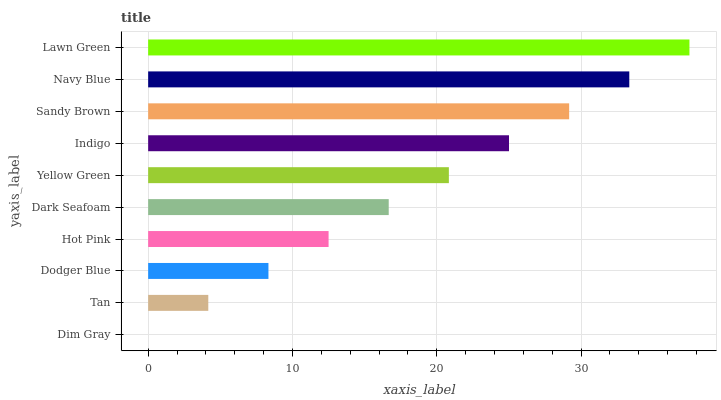Is Dim Gray the minimum?
Answer yes or no. Yes. Is Lawn Green the maximum?
Answer yes or no. Yes. Is Tan the minimum?
Answer yes or no. No. Is Tan the maximum?
Answer yes or no. No. Is Tan greater than Dim Gray?
Answer yes or no. Yes. Is Dim Gray less than Tan?
Answer yes or no. Yes. Is Dim Gray greater than Tan?
Answer yes or no. No. Is Tan less than Dim Gray?
Answer yes or no. No. Is Yellow Green the high median?
Answer yes or no. Yes. Is Dark Seafoam the low median?
Answer yes or no. Yes. Is Dim Gray the high median?
Answer yes or no. No. Is Tan the low median?
Answer yes or no. No. 